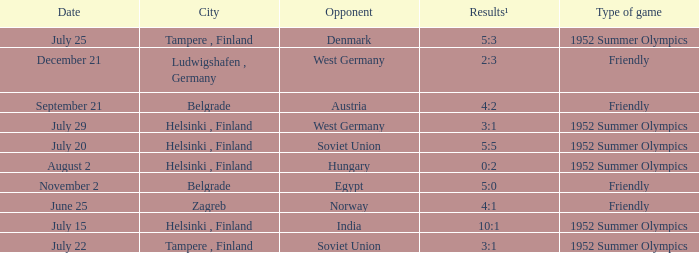Could you parse the entire table? {'header': ['Date', 'City', 'Opponent', 'Results¹', 'Type of game'], 'rows': [['July 25', 'Tampere , Finland', 'Denmark', '5:3', '1952 Summer Olympics'], ['December 21', 'Ludwigshafen , Germany', 'West Germany', '2:3', 'Friendly'], ['September 21', 'Belgrade', 'Austria', '4:2', 'Friendly'], ['July 29', 'Helsinki , Finland', 'West Germany', '3:1', '1952 Summer Olympics'], ['July 20', 'Helsinki , Finland', 'Soviet Union', '5:5', '1952 Summer Olympics'], ['August 2', 'Helsinki , Finland', 'Hungary', '0:2', '1952 Summer Olympics'], ['November 2', 'Belgrade', 'Egypt', '5:0', 'Friendly'], ['June 25', 'Zagreb', 'Norway', '4:1', 'Friendly'], ['July 15', 'Helsinki , Finland', 'India', '10:1', '1952 Summer Olympics'], ['July 22', 'Tampere , Finland', 'Soviet Union', '3:1', '1952 Summer Olympics']]} With the Type is game of friendly and the City Belgrade and November 2 as the Date what were the Results¹? 5:0. 